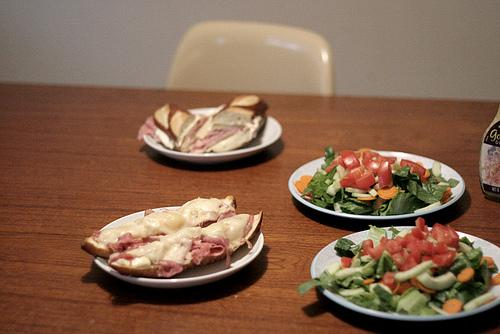Is the chair in the image meant for dining, and is it occupied? Yes, the chair is meant for dining, but it is not occupied in the image. Please enumerate the unique objects found within the image. Chair back, white wall, wooden table, two white plates, salad, sandwich, red tomatoes, green lettuce, sliced carrots, bottle of salad dressing. Estimate how many tomato slices are present in the salad. Several, likely around 6 to 10 slices, based on the object size and space. Identify and describe the setting of this picture. The setting is a dining area with a brown wooden table and a chair, with two plates of food placed on the table and a white wall in the background. Analyze and describe the overall sentiment expressed through the picture. The sentiment is inviting and pleasant, showcasing a delicious meal set in a simple dining area, creating a cozy atmosphere for dining. Examine the image and report any indication of people present. There are no visible people in the image. What type of food is being served on the plates? Salad with sliced tomatoes, carrots, lettuce, and an open face sandwich with meat and melted cheese. Depict the main ingredients in the open face sandwich served on the plate. Bread, meat, and melted cheese. Determine if the plates and table appear clean and well-presented. Yes, the plates and table appear clean and well-presented, displaying the food neatly arranged on the plate. Provide a caption for the overall scene in the image. A delicious meal served on a wooden table with two plates of salad and an open face sandwich, accompanied by a bottle of dressing, near a white wall. What meal event is occurring in this image? Serving lunch or dinner What type of sandwich is it? Open face sandwich Describe the location of the chair in the image. At the table in front of a white wall Is the bottle of salad dressing open or unopened? Unopened Are the tomatoes on the sandwich yellow? There are tomatoes in the image, but the tomatoes are described as red, not yellow. Is there ice cream for dessert on the table? There is no mention of dessert, specifically ice cream, on the table. Name the different food items on the white wall. Sandwich, salad with sliced tomatoes and carrots Is the salad dressing in a green bottle? The salad dressing is in a bottle, but the color of the bottle is not specified. Can you see a pizza on the table? There are sandwiches, salads, and other items on the table, but there is no mention of pizza. Scramble the following letters: Answer:  Are there three plates of food on the table? There are only two white plates of food mentioned, not three. Arrange the following words to create a descriptive sentence: tomatoes sliced on salad. Sliced tomatoes on salad Is the chair back blue and next to a black wall? The chair back is in front of a white wall, the color of the chair itself is not specified.  Given this phrase: "a f e c h i r", unscramble it to make a word. Chair Which vegetable is used in the salad besides lettuce? Carrots How many white plates are there in the image? Two What does the open face sandwich consist of? Bread, meat, melted cheese What kind of plates are the salads served on? White plates Select a word that matches the scrambled form "olalbd etvoltge" (Select one: balled tvolgte, bottled salad, a lettuce tale) Bottled salad Explain the appearance of the salad with specific details. Green lettuce, sliced tomatoes, sliced carrots, not dressed What is the state of the chef dressing for the salad? Bottle unopened Describe the food on a plate. Open face sandwich and salad with tomatoes and carrots What is the color of the table? Brown 